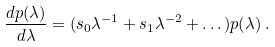<formula> <loc_0><loc_0><loc_500><loc_500>\frac { d p ( \lambda ) } { d \lambda } = ( s _ { 0 } \lambda ^ { - 1 } + s _ { 1 } \lambda ^ { - 2 } + \dots ) p ( \lambda ) \, .</formula> 